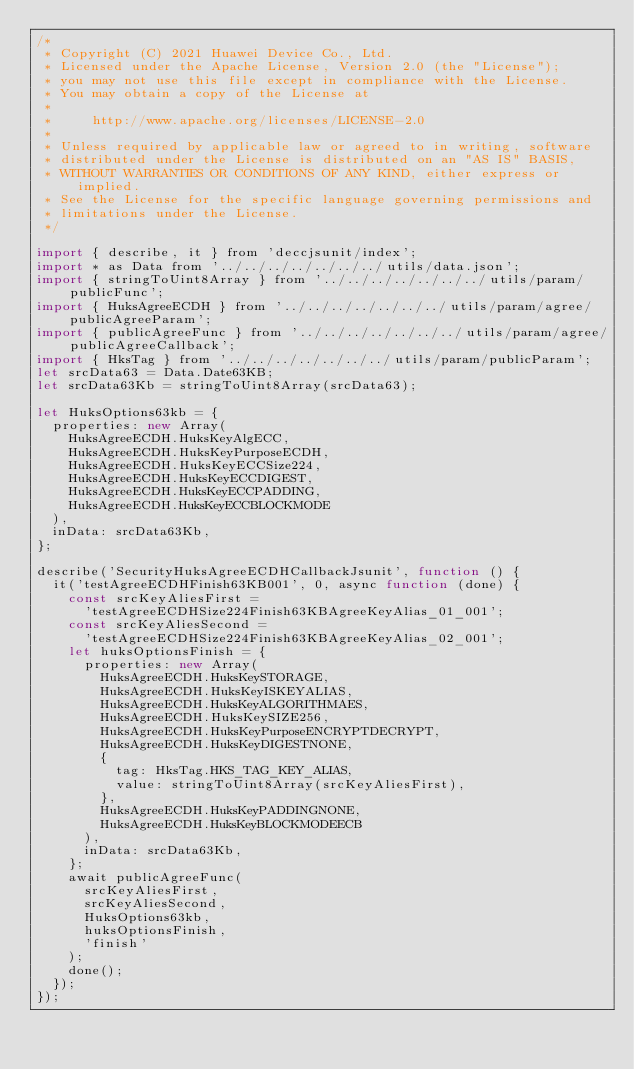Convert code to text. <code><loc_0><loc_0><loc_500><loc_500><_JavaScript_>/*
 * Copyright (C) 2021 Huawei Device Co., Ltd.
 * Licensed under the Apache License, Version 2.0 (the "License");
 * you may not use this file except in compliance with the License.
 * You may obtain a copy of the License at
 *
 *     http://www.apache.org/licenses/LICENSE-2.0
 *
 * Unless required by applicable law or agreed to in writing, software
 * distributed under the License is distributed on an "AS IS" BASIS,
 * WITHOUT WARRANTIES OR CONDITIONS OF ANY KIND, either express or implied.
 * See the License for the specific language governing permissions and
 * limitations under the License.
 */

import { describe, it } from 'deccjsunit/index';
import * as Data from '../../../../../../../utils/data.json';
import { stringToUint8Array } from '../../../../../../../utils/param/publicFunc';
import { HuksAgreeECDH } from '../../../../../../../utils/param/agree/publicAgreeParam';
import { publicAgreeFunc } from '../../../../../../../utils/param/agree/publicAgreeCallback';
import { HksTag } from '../../../../../../../utils/param/publicParam';
let srcData63 = Data.Date63KB;
let srcData63Kb = stringToUint8Array(srcData63);

let HuksOptions63kb = {
  properties: new Array(
    HuksAgreeECDH.HuksKeyAlgECC,
    HuksAgreeECDH.HuksKeyPurposeECDH,
    HuksAgreeECDH.HuksKeyECCSize224,
    HuksAgreeECDH.HuksKeyECCDIGEST,
    HuksAgreeECDH.HuksKeyECCPADDING,
    HuksAgreeECDH.HuksKeyECCBLOCKMODE
  ),
  inData: srcData63Kb,
};

describe('SecurityHuksAgreeECDHCallbackJsunit', function () {
  it('testAgreeECDHFinish63KB001', 0, async function (done) {
    const srcKeyAliesFirst =
      'testAgreeECDHSize224Finish63KBAgreeKeyAlias_01_001';
    const srcKeyAliesSecond =
      'testAgreeECDHSize224Finish63KBAgreeKeyAlias_02_001';
    let huksOptionsFinish = {
      properties: new Array(
        HuksAgreeECDH.HuksKeySTORAGE,
        HuksAgreeECDH.HuksKeyISKEYALIAS,
        HuksAgreeECDH.HuksKeyALGORITHMAES,
        HuksAgreeECDH.HuksKeySIZE256,
        HuksAgreeECDH.HuksKeyPurposeENCRYPTDECRYPT,
        HuksAgreeECDH.HuksKeyDIGESTNONE,
        {
          tag: HksTag.HKS_TAG_KEY_ALIAS,
          value: stringToUint8Array(srcKeyAliesFirst),
        },
        HuksAgreeECDH.HuksKeyPADDINGNONE,
        HuksAgreeECDH.HuksKeyBLOCKMODEECB
      ),
      inData: srcData63Kb,
    };
    await publicAgreeFunc(
      srcKeyAliesFirst,
      srcKeyAliesSecond,
      HuksOptions63kb,
      huksOptionsFinish,
      'finish'
    );
    done();
  });
});
</code> 